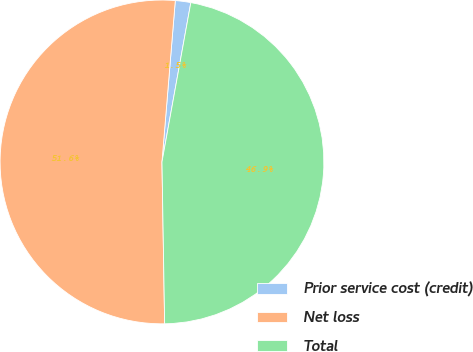Convert chart to OTSL. <chart><loc_0><loc_0><loc_500><loc_500><pie_chart><fcel>Prior service cost (credit)<fcel>Net loss<fcel>Total<nl><fcel>1.54%<fcel>51.58%<fcel>46.89%<nl></chart> 